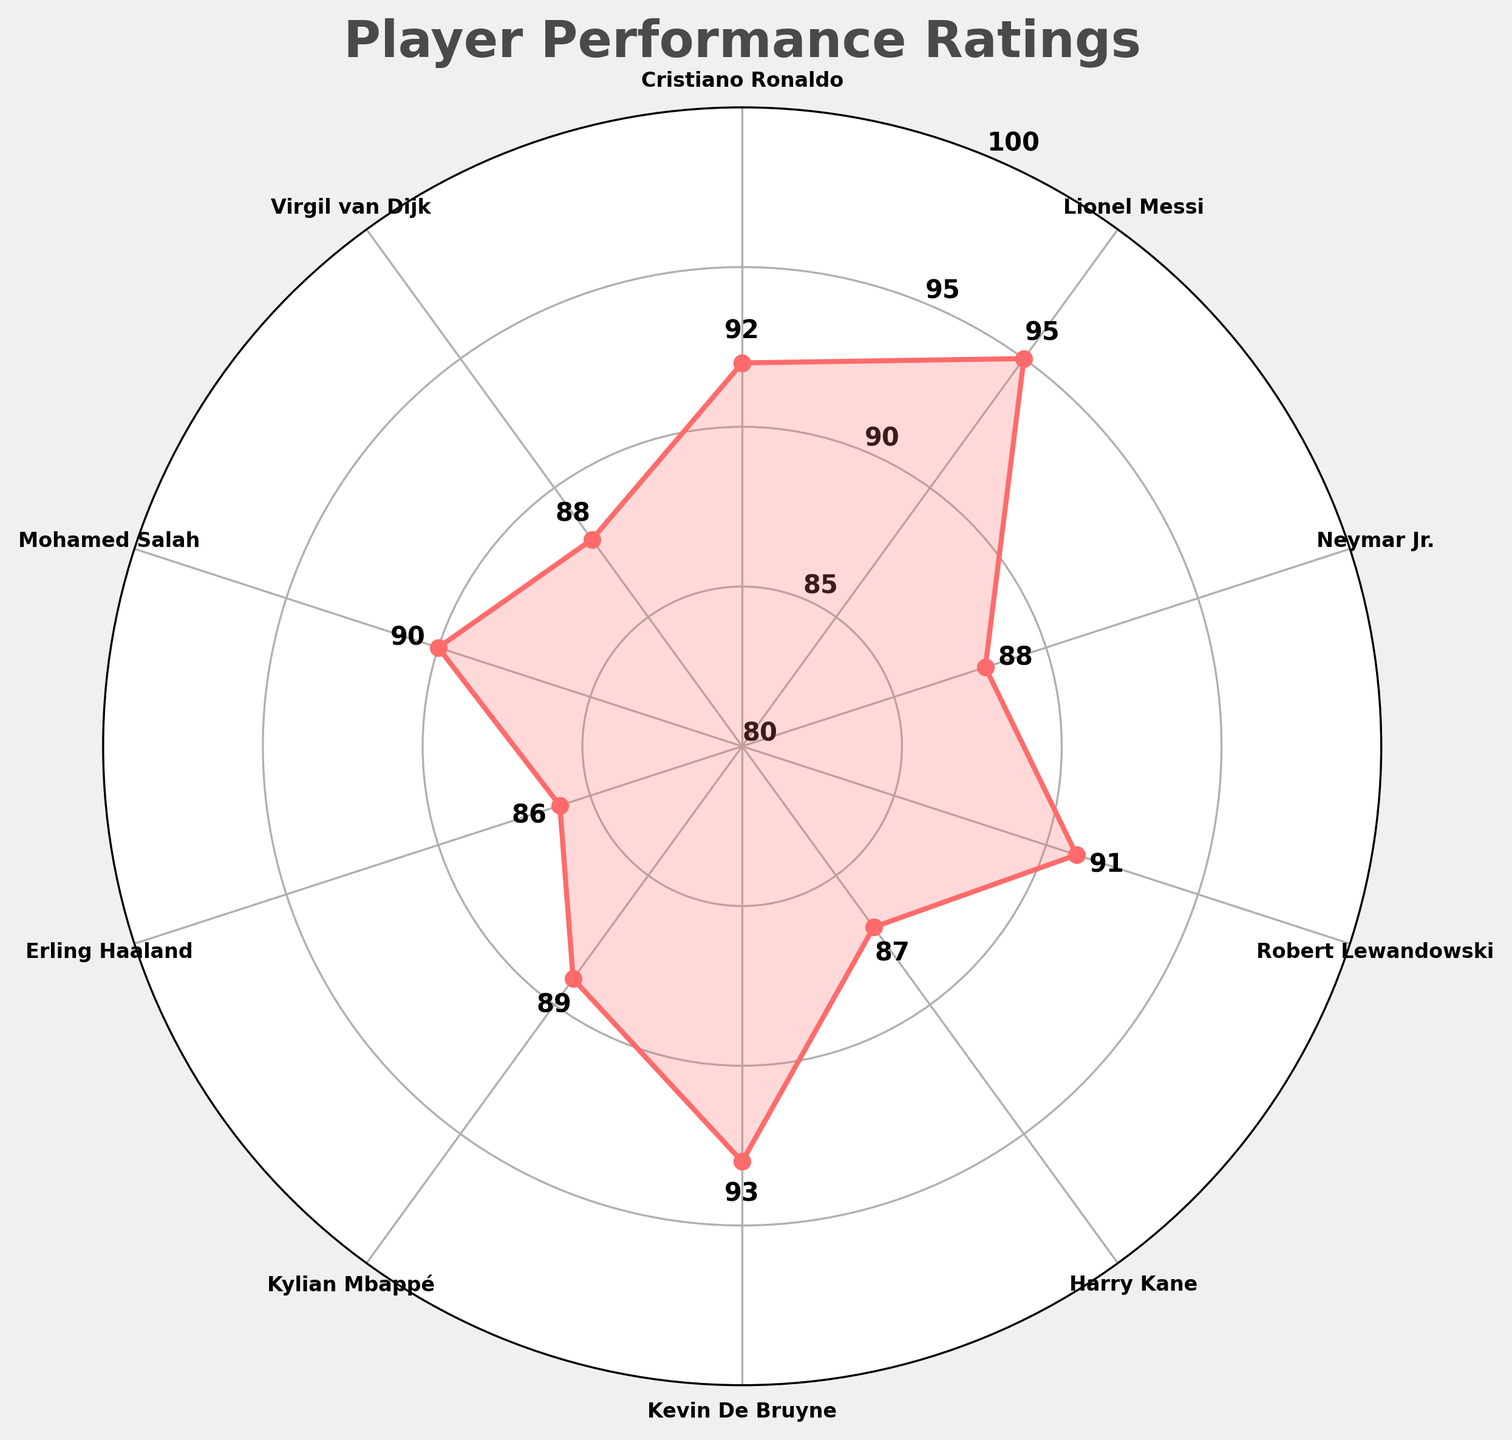Who has the highest performance rating? By looking at the figure, you can see that Lionel Messi has the highest rating among all the players, as his rating point is the furthest out toward the edge of the gauge.
Answer: Lionel Messi What is the average performance rating of all players? To find the average performance rating, sum up the individual ratings of all players: 92 (Ronaldo) + 95 (Messi) + 88 (Neymar) + 91 (Lewandowski) + 87 (Kane) + 93 (De Bruyne) + 89 (Mbappé) + 86 (Haaland) + 90 (Salah) + 88 (van Dijk) = 899. Dividing by the number of players, 899 / 10 = 89.9.
Answer: 89.9 Which player has a performance rating closest to the average? The average rating is 89.9. By comparing the individual ratings, Kylian Mbappé has a performance rating of 89, which is closest to the average.
Answer: Kylian Mbappé How many players have a performance rating above 90? By observing the ratings figures for each player, you see that Ronaldo (92), Messi (95), Lewandowski (91), De Bruyne (93), and Salah (90) have ratings above 90. Counting these players gives a total of 5 players.
Answer: 5 What is the performance rating for the player with the lowest rating? Looking at the most inward plot points, Erling Haaland has the rating closest to the center, indicating the lowest rating, which is 86.
Answer: Erling Haaland How much higher is Kevin De Bruyne's performance rating compared to Harry Kane's? Kevin De Bruyne has a rating of 93 and Harry Kane has a rating of 87. The difference between their ratings is 93 - 87 = 6.
Answer: 6 Which players have exactly the same performance rating? By examining the ratings of each player, you can see that Neymar Jr. and Virgil van Dijk both have a rating of 88.
Answer: Neymar Jr. and Virgil van Dijk What is the range of performance ratings within the plot? To find the range, subtract the lowest rating from the highest rating. The highest rating is 95 (Messi) and the lowest is 86 (Haaland). Therefore, 95 - 86 = 9.
Answer: 9 Is Mohamed Salah’s rating higher than Neymar Jr.'s? Comparing their ratings, Mohamed Salah has a rating of 90 while Neymar Jr. has a rating of 88. Therefore, Salah’s rating is higher.
Answer: Yes 